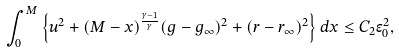<formula> <loc_0><loc_0><loc_500><loc_500>\int ^ { M } _ { 0 } \left \{ u ^ { 2 } + ( M - x ) ^ { \frac { \gamma - 1 } { \gamma } } ( g - g _ { \infty } ) ^ { 2 } + ( r - r _ { \infty } ) ^ { 2 } \right \} d x \leq C _ { 2 } \epsilon _ { 0 } ^ { 2 } ,</formula> 